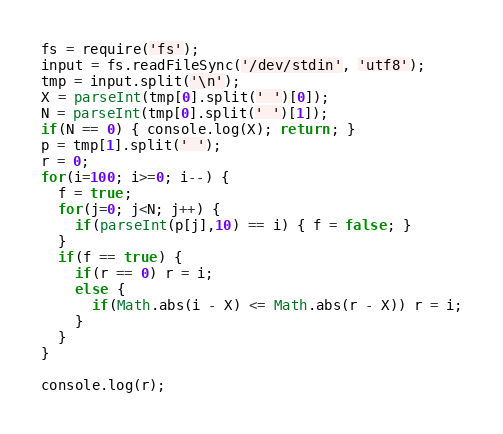Convert code to text. <code><loc_0><loc_0><loc_500><loc_500><_JavaScript_>fs = require('fs');
input = fs.readFileSync('/dev/stdin', 'utf8');
tmp = input.split('\n');
X = parseInt(tmp[0].split(' ')[0]);
N = parseInt(tmp[0].split(' ')[1]);
if(N == 0) { console.log(X); return; }
p = tmp[1].split(' ');
r = 0;
for(i=100; i>=0; i--) {
  f = true;
  for(j=0; j<N; j++) {
    if(parseInt(p[j],10) == i) { f = false; }
  }
  if(f == true) {
    if(r == 0) r = i;
    else {
      if(Math.abs(i - X) <= Math.abs(r - X)) r = i;
    }
  }
}

console.log(r);
</code> 